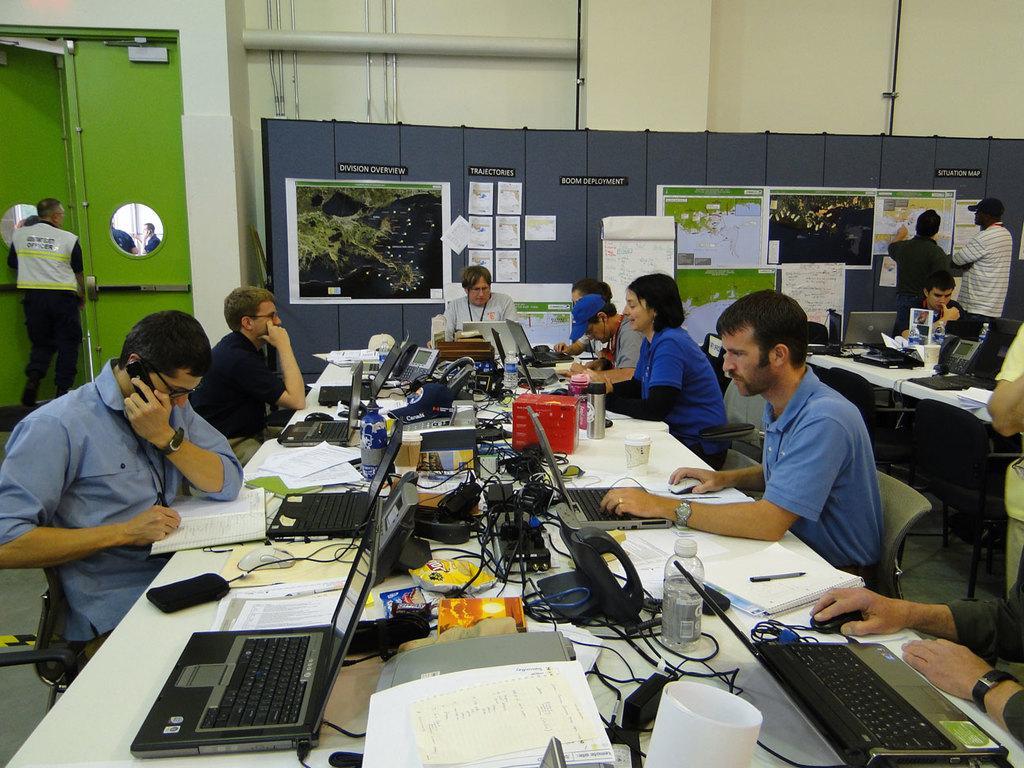How would you summarize this image in a sentence or two? In this image there are few people sitting on their chairs, in between them there is a table with laptops, bottles, cables, books, papers and few other objects placed on it. In the background there is a wall with posters and papers on it. on the left side of the image there is a person standing in front of the door. 